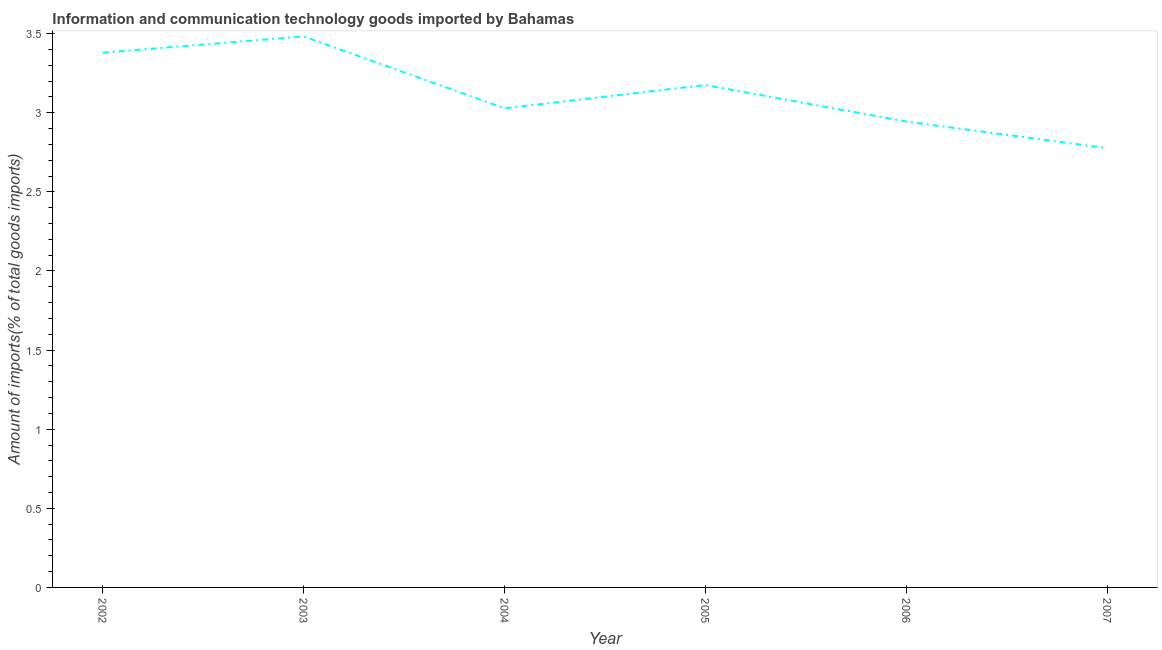What is the amount of ict goods imports in 2005?
Provide a succinct answer. 3.18. Across all years, what is the maximum amount of ict goods imports?
Offer a terse response. 3.48. Across all years, what is the minimum amount of ict goods imports?
Your answer should be compact. 2.78. In which year was the amount of ict goods imports maximum?
Your answer should be very brief. 2003. What is the sum of the amount of ict goods imports?
Offer a very short reply. 18.79. What is the difference between the amount of ict goods imports in 2002 and 2003?
Your answer should be very brief. -0.1. What is the average amount of ict goods imports per year?
Your answer should be compact. 3.13. What is the median amount of ict goods imports?
Offer a very short reply. 3.1. Do a majority of the years between 2006 and 2004 (inclusive) have amount of ict goods imports greater than 0.6 %?
Keep it short and to the point. No. What is the ratio of the amount of ict goods imports in 2002 to that in 2004?
Ensure brevity in your answer.  1.12. Is the amount of ict goods imports in 2003 less than that in 2006?
Provide a short and direct response. No. What is the difference between the highest and the second highest amount of ict goods imports?
Give a very brief answer. 0.1. What is the difference between the highest and the lowest amount of ict goods imports?
Provide a short and direct response. 0.71. Does the amount of ict goods imports monotonically increase over the years?
Your answer should be compact. No. How many lines are there?
Provide a short and direct response. 1. How many years are there in the graph?
Keep it short and to the point. 6. Are the values on the major ticks of Y-axis written in scientific E-notation?
Your answer should be very brief. No. Does the graph contain any zero values?
Offer a terse response. No. What is the title of the graph?
Keep it short and to the point. Information and communication technology goods imported by Bahamas. What is the label or title of the Y-axis?
Offer a very short reply. Amount of imports(% of total goods imports). What is the Amount of imports(% of total goods imports) in 2002?
Your answer should be very brief. 3.38. What is the Amount of imports(% of total goods imports) of 2003?
Make the answer very short. 3.48. What is the Amount of imports(% of total goods imports) in 2004?
Give a very brief answer. 3.03. What is the Amount of imports(% of total goods imports) of 2005?
Make the answer very short. 3.18. What is the Amount of imports(% of total goods imports) of 2006?
Your answer should be compact. 2.94. What is the Amount of imports(% of total goods imports) in 2007?
Keep it short and to the point. 2.78. What is the difference between the Amount of imports(% of total goods imports) in 2002 and 2003?
Provide a short and direct response. -0.1. What is the difference between the Amount of imports(% of total goods imports) in 2002 and 2004?
Give a very brief answer. 0.35. What is the difference between the Amount of imports(% of total goods imports) in 2002 and 2005?
Keep it short and to the point. 0.2. What is the difference between the Amount of imports(% of total goods imports) in 2002 and 2006?
Provide a succinct answer. 0.44. What is the difference between the Amount of imports(% of total goods imports) in 2002 and 2007?
Ensure brevity in your answer.  0.6. What is the difference between the Amount of imports(% of total goods imports) in 2003 and 2004?
Provide a succinct answer. 0.45. What is the difference between the Amount of imports(% of total goods imports) in 2003 and 2005?
Make the answer very short. 0.31. What is the difference between the Amount of imports(% of total goods imports) in 2003 and 2006?
Your response must be concise. 0.54. What is the difference between the Amount of imports(% of total goods imports) in 2003 and 2007?
Provide a succinct answer. 0.71. What is the difference between the Amount of imports(% of total goods imports) in 2004 and 2005?
Offer a terse response. -0.15. What is the difference between the Amount of imports(% of total goods imports) in 2004 and 2006?
Give a very brief answer. 0.08. What is the difference between the Amount of imports(% of total goods imports) in 2004 and 2007?
Ensure brevity in your answer.  0.25. What is the difference between the Amount of imports(% of total goods imports) in 2005 and 2006?
Give a very brief answer. 0.23. What is the difference between the Amount of imports(% of total goods imports) in 2005 and 2007?
Provide a short and direct response. 0.4. What is the difference between the Amount of imports(% of total goods imports) in 2006 and 2007?
Your answer should be very brief. 0.17. What is the ratio of the Amount of imports(% of total goods imports) in 2002 to that in 2004?
Provide a succinct answer. 1.12. What is the ratio of the Amount of imports(% of total goods imports) in 2002 to that in 2005?
Provide a succinct answer. 1.06. What is the ratio of the Amount of imports(% of total goods imports) in 2002 to that in 2006?
Provide a short and direct response. 1.15. What is the ratio of the Amount of imports(% of total goods imports) in 2002 to that in 2007?
Offer a very short reply. 1.22. What is the ratio of the Amount of imports(% of total goods imports) in 2003 to that in 2004?
Your answer should be compact. 1.15. What is the ratio of the Amount of imports(% of total goods imports) in 2003 to that in 2005?
Give a very brief answer. 1.1. What is the ratio of the Amount of imports(% of total goods imports) in 2003 to that in 2006?
Your answer should be very brief. 1.18. What is the ratio of the Amount of imports(% of total goods imports) in 2003 to that in 2007?
Give a very brief answer. 1.25. What is the ratio of the Amount of imports(% of total goods imports) in 2004 to that in 2005?
Make the answer very short. 0.95. What is the ratio of the Amount of imports(% of total goods imports) in 2004 to that in 2006?
Offer a very short reply. 1.03. What is the ratio of the Amount of imports(% of total goods imports) in 2004 to that in 2007?
Give a very brief answer. 1.09. What is the ratio of the Amount of imports(% of total goods imports) in 2005 to that in 2006?
Give a very brief answer. 1.08. What is the ratio of the Amount of imports(% of total goods imports) in 2005 to that in 2007?
Offer a very short reply. 1.14. What is the ratio of the Amount of imports(% of total goods imports) in 2006 to that in 2007?
Ensure brevity in your answer.  1.06. 